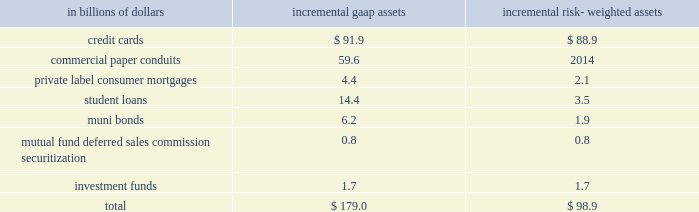Commitments .
For a further description of the loan loss reserve and related accounts , see 201cmanaging global risk 201d and notes 1 and 18 to the consolidated financial statements on pages 51 , 122 and 165 , respectively .
Securitizations the company securitizes a number of different asset classes as a means of strengthening its balance sheet and accessing competitive financing rates in the market .
Under these securitization programs , assets are sold into a trust and used as collateral by the trust to obtain financing .
The cash flows from assets in the trust service the corresponding trust securities .
If the structure of the trust meets certain accounting guidelines , trust assets are treated as sold and are no longer reflected as assets of the company .
If these guidelines are not met , the assets continue to be recorded as the company 2019s assets , with the financing activity recorded as liabilities on citigroup 2019s balance sheet .
Citigroup also assists its clients in securitizing their financial assets and packages and securitizes financial assets purchased in the financial markets .
The company may also provide administrative , asset management , underwriting , liquidity facilities and/or other services to the resulting securitization entities and may continue to service some of these financial assets .
Elimination of qspes and changes in the fin 46 ( r ) consolidation model the fasb has issued an exposure draft of a proposed standard that would eliminate qualifying special purpose entities ( qspes ) from the guidance in fasb statement no .
140 , accounting for transfers and servicing of financial assets and extinguishments of liabilities ( sfas 140 ) .
While the proposed standard has not been finalized , if it is issued in its current form it will have a significant impact on citigroup 2019s consolidated financial statements as the company will lose sales treatment for certain assets previously sold to a qspe , as well as for certain future sales , and for certain transfers of portions of assets that do not meet the proposed definition of 201cparticipating interests . 201d this proposed revision could become effective on january 1 , 2010 .
In connection with the proposed changes to sfas 140 , the fasb has also issued a separate exposure draft of a proposed standard that proposes three key changes to the consolidation model in fasb interpretation no .
46 ( revised december 2003 ) , 201cconsolidation of variable interest entities 201d ( fin 46 ( r ) ) .
First , the revised standard would include former qspes in the scope of fin 46 ( r ) .
In addition , fin 46 ( r ) would be amended to change the method of analyzing which party to a variable interest entity ( vie ) should consolidate the vie ( such consolidating entity is referred to as the 201cprimary beneficiary 201d ) to a qualitative determination of power combined with benefits or losses instead of the current risks and rewards model .
Finally , the proposed standard would require that the analysis of primary beneficiaries be re-evaluated whenever circumstances change .
The existing standard requires reconsideration only when specified reconsideration events occur .
The fasb is currently deliberating these proposed standards , and they are , accordingly , still subject to change .
Since qspes will likely be eliminated from sfas 140 and thus become subject to fin 46 ( r ) consolidation guidance and because the fin 46 ( r ) method of determining which party must consolidate a vie will likely change should this proposed standard become effective , the company expects to consolidate certain of the currently unconsolidated vies and qspes with which citigroup was involved as of december 31 , 2008 .
The company 2019s estimate of the incremental impact of adopting these changes on citigroup 2019s consolidated balance sheets and risk-weighted assets , based on december 31 , 2008 balances , our understanding of the proposed changes to the standards and a proposed january 1 , 2010 effective date , is presented below .
The actual impact of adopting the amended standards as of january 1 , 2010 could materially differ .
The pro forma impact of the proposed changes on gaap assets and risk- weighted assets , assuming application of existing risk-based capital rules , at january 1 , 2010 ( based on the balances at december 31 , 2008 ) would result in the consolidation of incremental assets as follows: .
The table reflects ( i ) the estimated portion of the assets of qspes to which citigroup , acting as principal , has transferred assets and received sales treatment as of december 31 , 2008 ( totaling approximately $ 822.1 billion ) , and ( ii ) the estimated assets of significant unconsolidated vies as of december 31 , 2008 with which citigroup is involved ( totaling approximately $ 288.0 billion ) that would be consolidated under the proposal .
Due to the variety of transaction structures and level of the company 2019s involvement in individual qspes and vies , only a subset of the qspes and vies with which the company is involved are expected to be consolidated under the proposed change .
A complete description of the company 2019s accounting for securitized assets can be found in note 1 to the consolidated financial statements on page 122. .
On citigroup 2019s consolidated balance sheets based on the balances of 2008 what was the ratio of the total gaap assets to the risk- weighted assets? 
Rationale: on citigroup 2019s consolidated balance sheets based on the balances of 2008 there was $ 1.881 of total gaap assets for each $ 1 of the risk- weighted assets
Computations: (179.0 / 98.9)
Answer: 1.80991. 